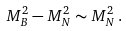<formula> <loc_0><loc_0><loc_500><loc_500>M _ { B } ^ { 2 } - M _ { N } ^ { 2 } \sim M _ { N } ^ { 2 } \, .</formula> 